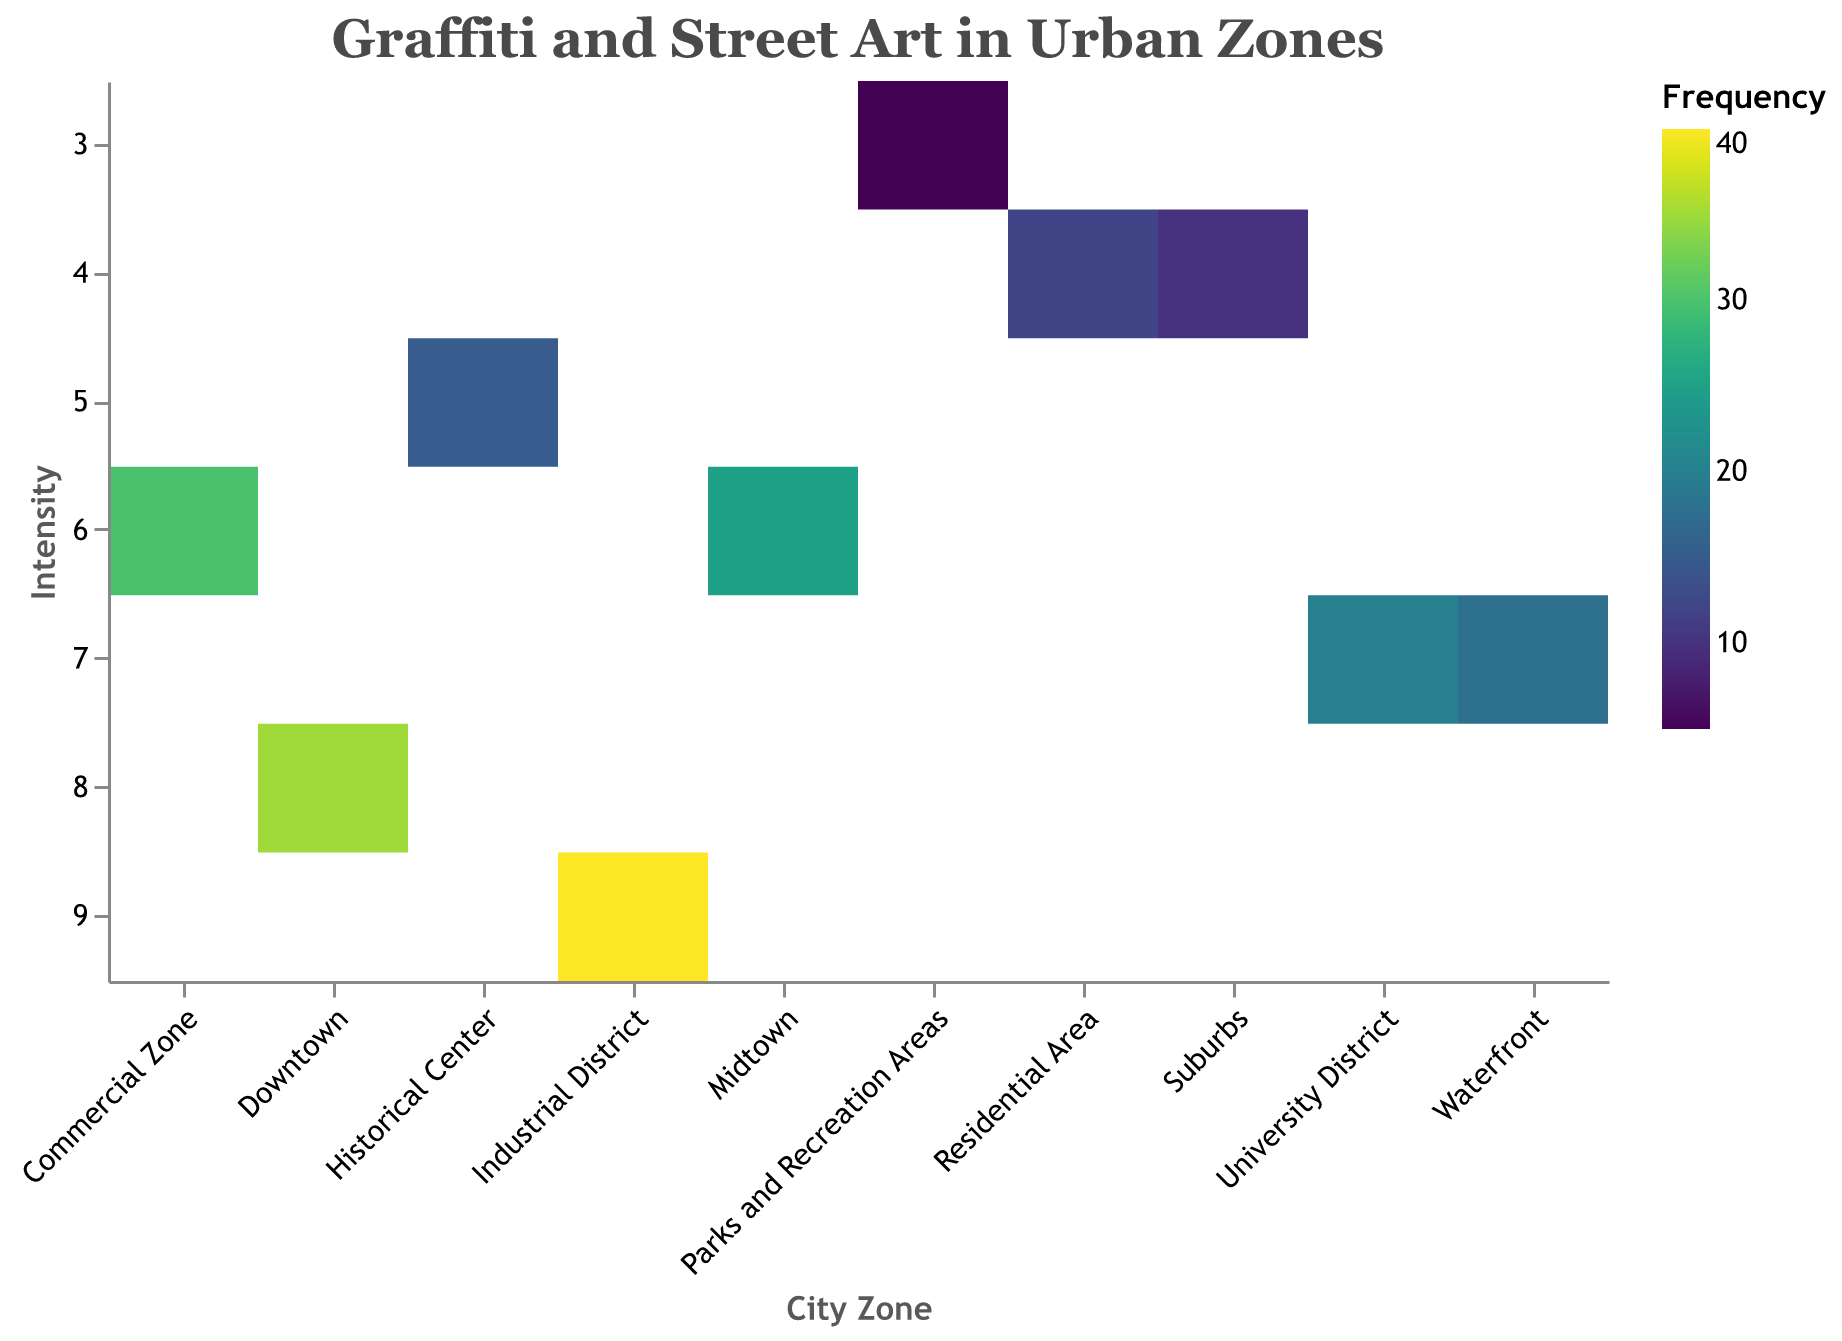What is the title of the heatmap? The title is usually placed at the top of the figure. In this case, the title is "Graffiti and Street Art in Urban Zones".
Answer: Graffiti and Street Art in Urban Zones Which city zone has the highest frequency of graffiti and street art? By looking at the color legend and comparing the color intensities, the "Industrial District" has the darkest color, indicating the highest frequency.
Answer: Industrial District What is the intensity level in the University District? The y-axis represents intensity and the cells are color-coded accordingly. For the University District, the intensity is marked at 7.
Answer: 7 Which two city zones have the same intensity level but different frequencies? By scanning the y-axis, we can see that "Midtown" and "Commercial Zone" both have an intensity of 6 but different frequencies, 25 and 30 respectively.
Answer: Midtown and Commercial Zone What is the color scheme used in the heatmap? The legend specifies the color scheme used, which is "viridis". This scheme ranges from dark to light colors as frequency increases.
Answer: viridis Compare the frequency of graffiti and street art in Downtown and Midtown. Which one is higher? Downtown and Midtown can be compared directly through their color intensity. Downtown has a darker shade indicating a higher frequency than the Midtown.
Answer: Downtown Which city zone has the lowest frequency and intensity of graffiti and street art? By looking at the lightest color and the lowest position on both axes, "Parks and Recreation Areas" have the lowest values.
Answer: Parks and Recreation Areas How does the frequency in the Residential Area compare to the Suburbs? Both city zones have the same intensity, but Residential Area has a frequency of 12, which is higher than the Suburbs' frequency of 10.
Answer: Residential Area Summing up the frequency values for Downtown and the Industrial District, what is the result? Adding the frequency values directly, 35 (Downtown) + 40 (Industrial District) = 75.
Answer: 75 What is the median intensity value across all city zones? Listing intensities in order: 3, 4, 4, 4, 5, 6, 6, 7, 7, 8, 9. The median is the middle value, which is 6.
Answer: 6 